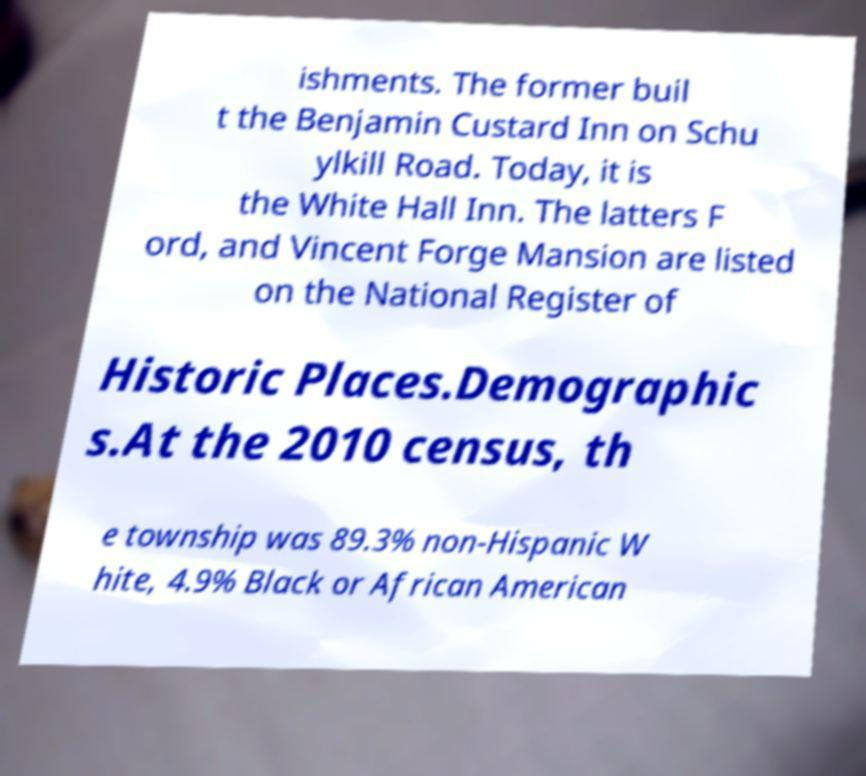Please read and relay the text visible in this image. What does it say? ishments. The former buil t the Benjamin Custard Inn on Schu ylkill Road. Today, it is the White Hall Inn. The latters F ord, and Vincent Forge Mansion are listed on the National Register of Historic Places.Demographic s.At the 2010 census, th e township was 89.3% non-Hispanic W hite, 4.9% Black or African American 